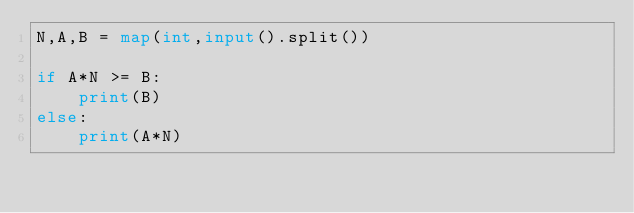<code> <loc_0><loc_0><loc_500><loc_500><_Python_>N,A,B = map(int,input().split())

if A*N >= B:
    print(B)
else:
    print(A*N)</code> 